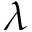<formula> <loc_0><loc_0><loc_500><loc_500>\lambda</formula> 